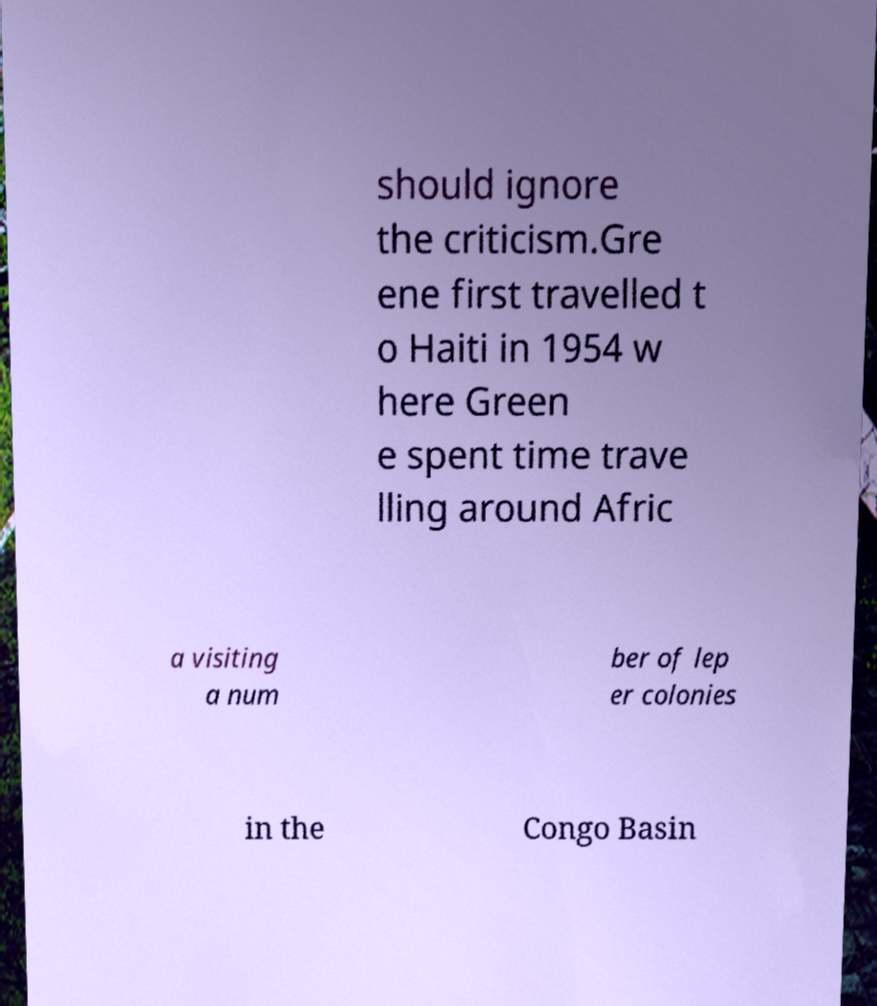For documentation purposes, I need the text within this image transcribed. Could you provide that? should ignore the criticism.Gre ene first travelled t o Haiti in 1954 w here Green e spent time trave lling around Afric a visiting a num ber of lep er colonies in the Congo Basin 